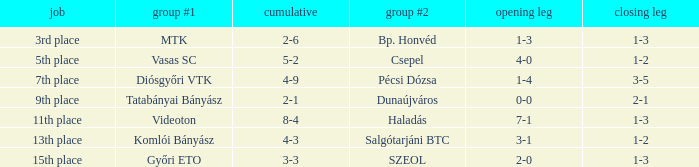Give me the full table as a dictionary. {'header': ['job', 'group #1', 'cumulative', 'group #2', 'opening leg', 'closing leg'], 'rows': [['3rd place', 'MTK', '2-6', 'Bp. Honvéd', '1-3', '1-3'], ['5th place', 'Vasas SC', '5-2', 'Csepel', '4-0', '1-2'], ['7th place', 'Diósgyőri VTK', '4-9', 'Pécsi Dózsa', '1-4', '3-5'], ['9th place', 'Tatabányai Bányász', '2-1', 'Dunaújváros', '0-0', '2-1'], ['11th place', 'Videoton', '8-4', 'Haladás', '7-1', '1-3'], ['13th place', 'Komlói Bányász', '4-3', 'Salgótarjáni BTC', '3-1', '1-2'], ['15th place', 'Győri ETO', '3-3', 'SZEOL', '2-0', '1-3']]} What is the 1st leg with a 4-3 agg.? 3-1. 